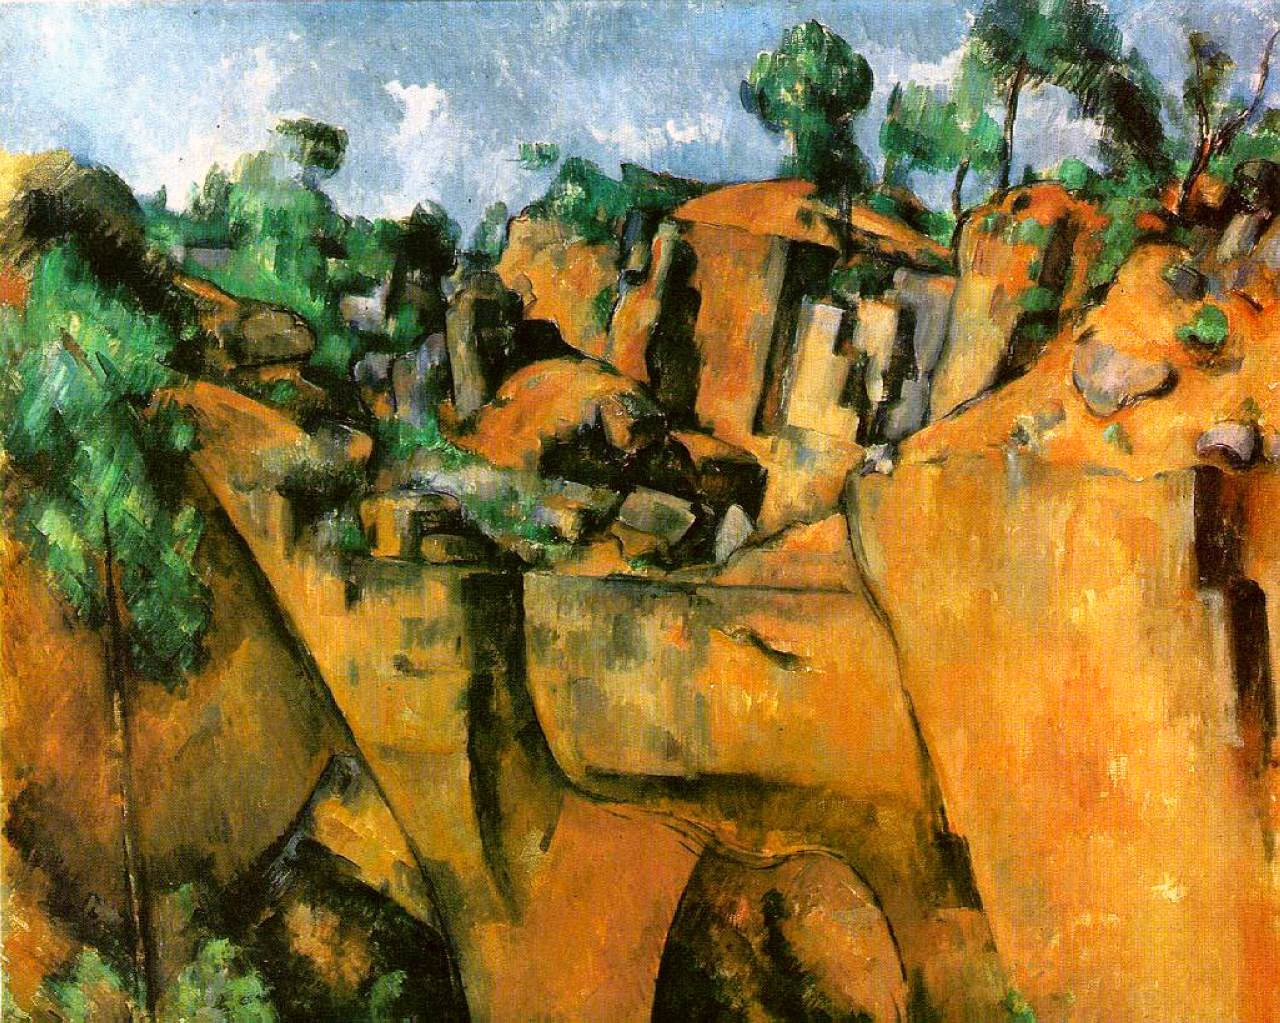What is this photo about? This image is not a photo but an oil painting, characterized by a dynamic post-impressionist style. The landscape depicted is rugged and natural, with homes nestled among rock formations and dense vegetation, alluding to perhaps a rural or secluded setting. The artist employs vibrant colors and bold, visible brushstrokes, which energize the scene and evoke a sense of the untamed natural world. The use of green, orange, and brown not only brings the landscape to life but also might suggest the time of day or season, possibly late summer or early autumn. The painting invites viewers to consider the relationship between human habitation and nature, a recurring theme in post-impressionist works. 